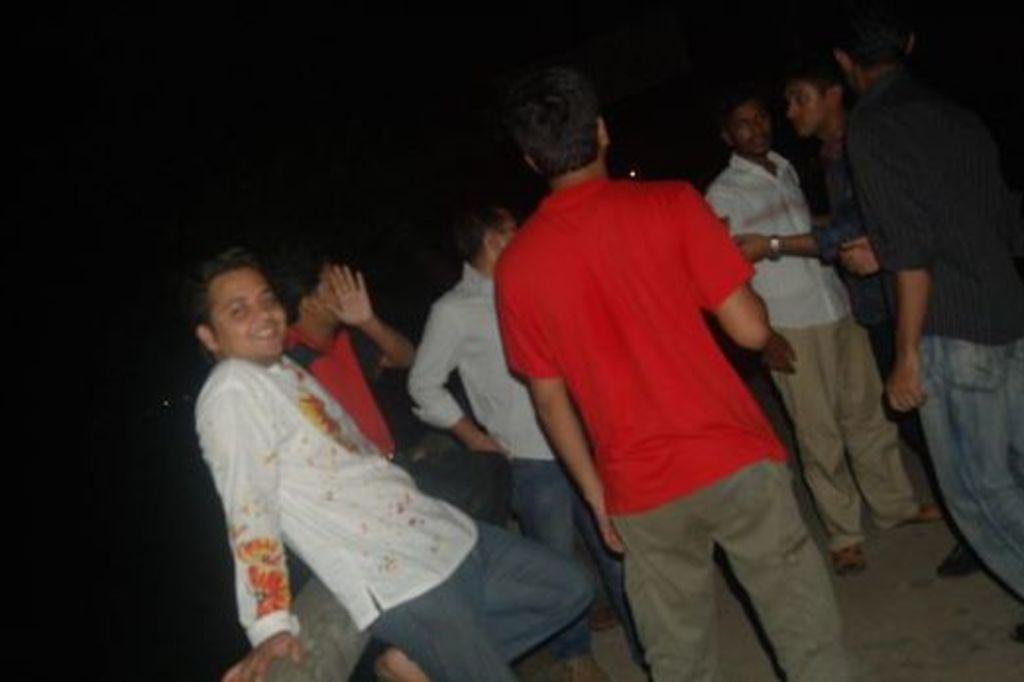What is happening in the image? There are people standing on the ground in the image. Can you describe the position of one of the people in the image? There is a person standing near a wall in the image. What can be observed about the lighting in the image? The background of the image is dark. What type of playground equipment can be seen in the image? There is no playground equipment present in the image. How many birds are perched on the wall in the image? There are no birds visible in the image. 